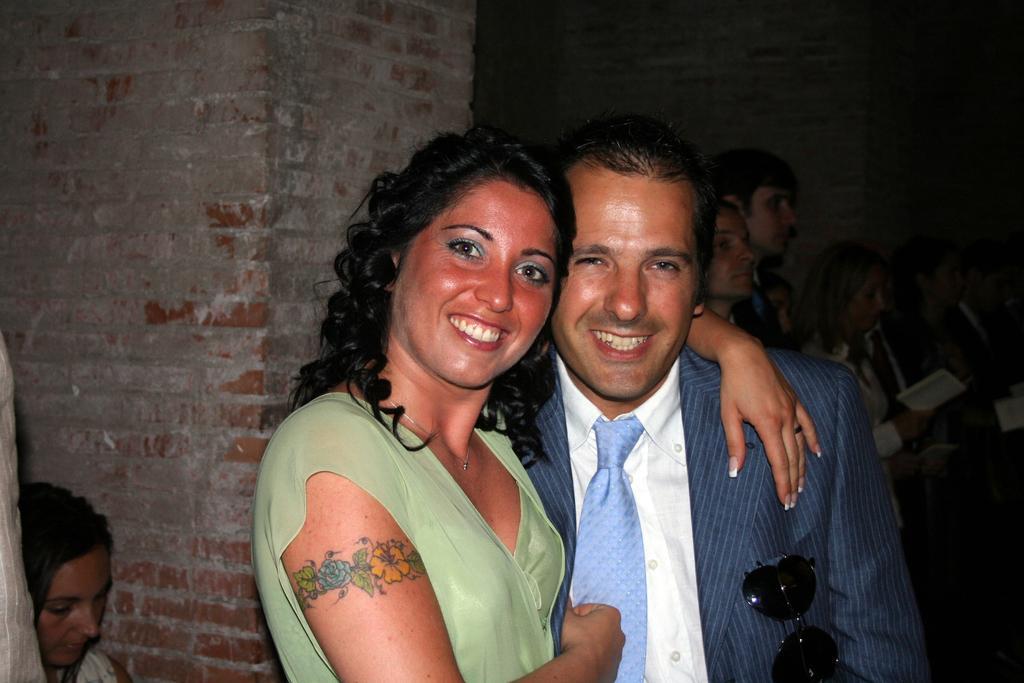Can you describe this image briefly? On the left side, there is a woman. Beside her, there is another woman in green color T-shirt, smiling and placing a hand on the shoulder of a person who is in a suit. In the background, there are other persons and a brick wall. 